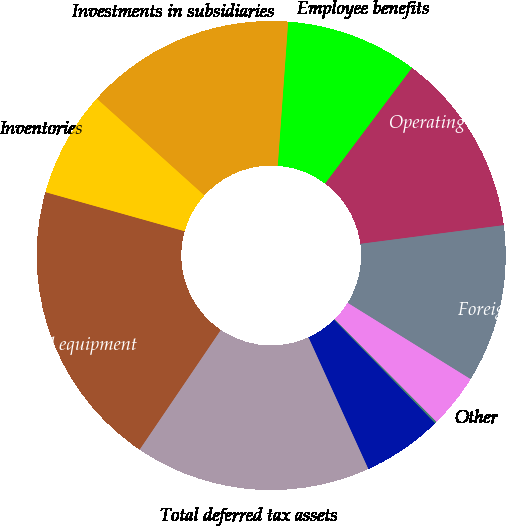Convert chart to OTSL. <chart><loc_0><loc_0><loc_500><loc_500><pie_chart><fcel>Employee benefits<fcel>Operating loss carryforwards<fcel>Foreign tax credits<fcel>Other<fcel>State<fcel>Foreign (c)<fcel>Total deferred tax assets<fcel>Property plant and equipment<fcel>Inventories<fcel>Investments in subsidiaries<nl><fcel>9.1%<fcel>12.69%<fcel>10.9%<fcel>3.72%<fcel>0.13%<fcel>5.52%<fcel>16.28%<fcel>19.87%<fcel>7.31%<fcel>14.48%<nl></chart> 